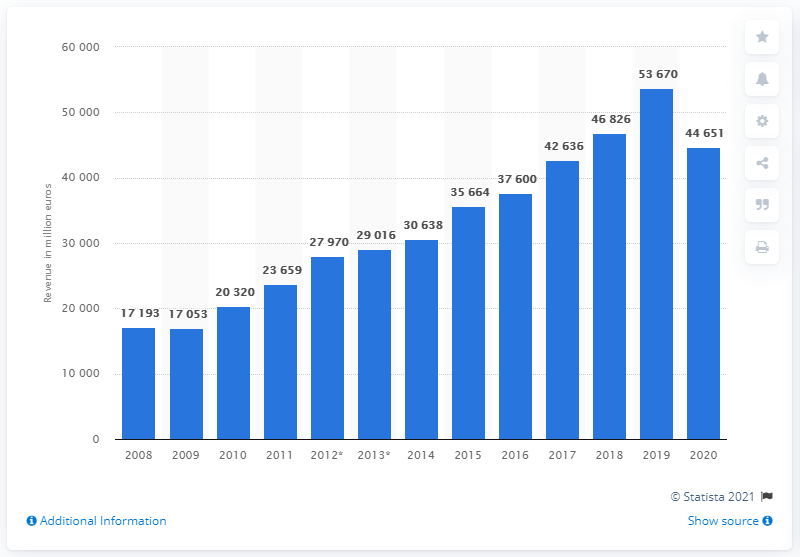Specify some key components in this picture. In 2020, the LVMH Group generated a total revenue of 44,651... 